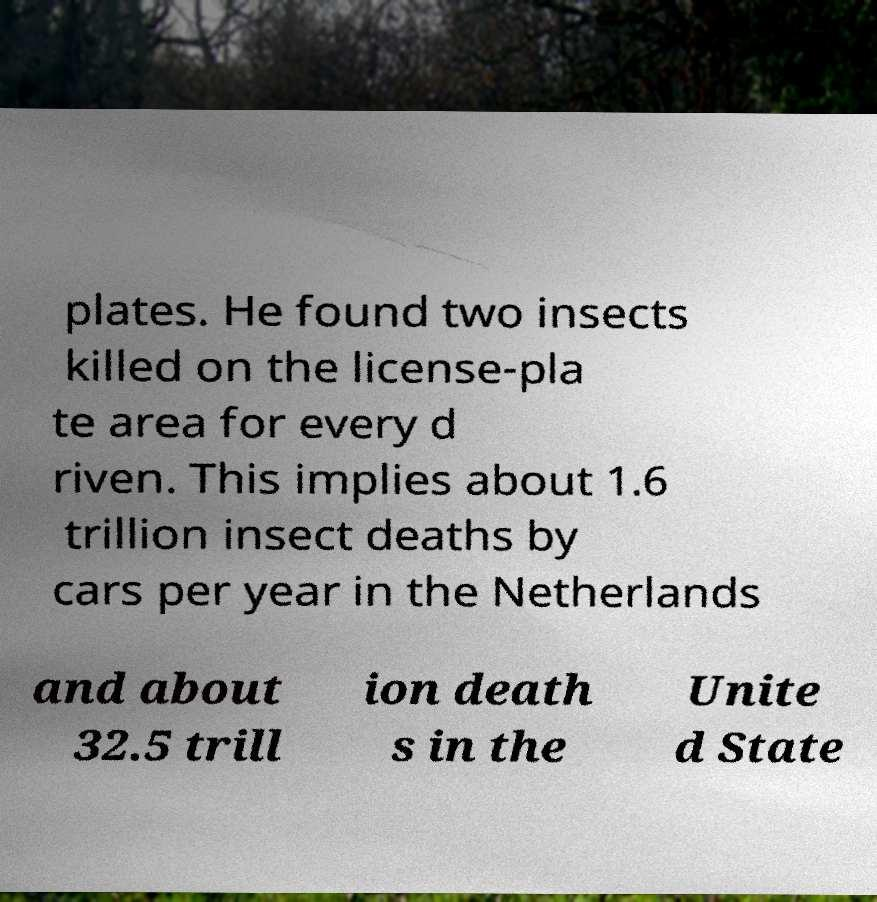Could you extract and type out the text from this image? plates. He found two insects killed on the license-pla te area for every d riven. This implies about 1.6 trillion insect deaths by cars per year in the Netherlands and about 32.5 trill ion death s in the Unite d State 